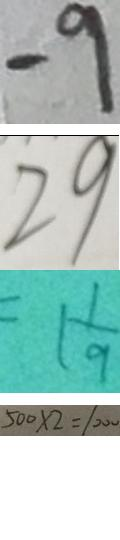Convert formula to latex. <formula><loc_0><loc_0><loc_500><loc_500>- 9 
 2 9 
 = 1 \frac { 1 } { 9 } 
 5 0 0 \times 2 = 1 0 0 0</formula> 